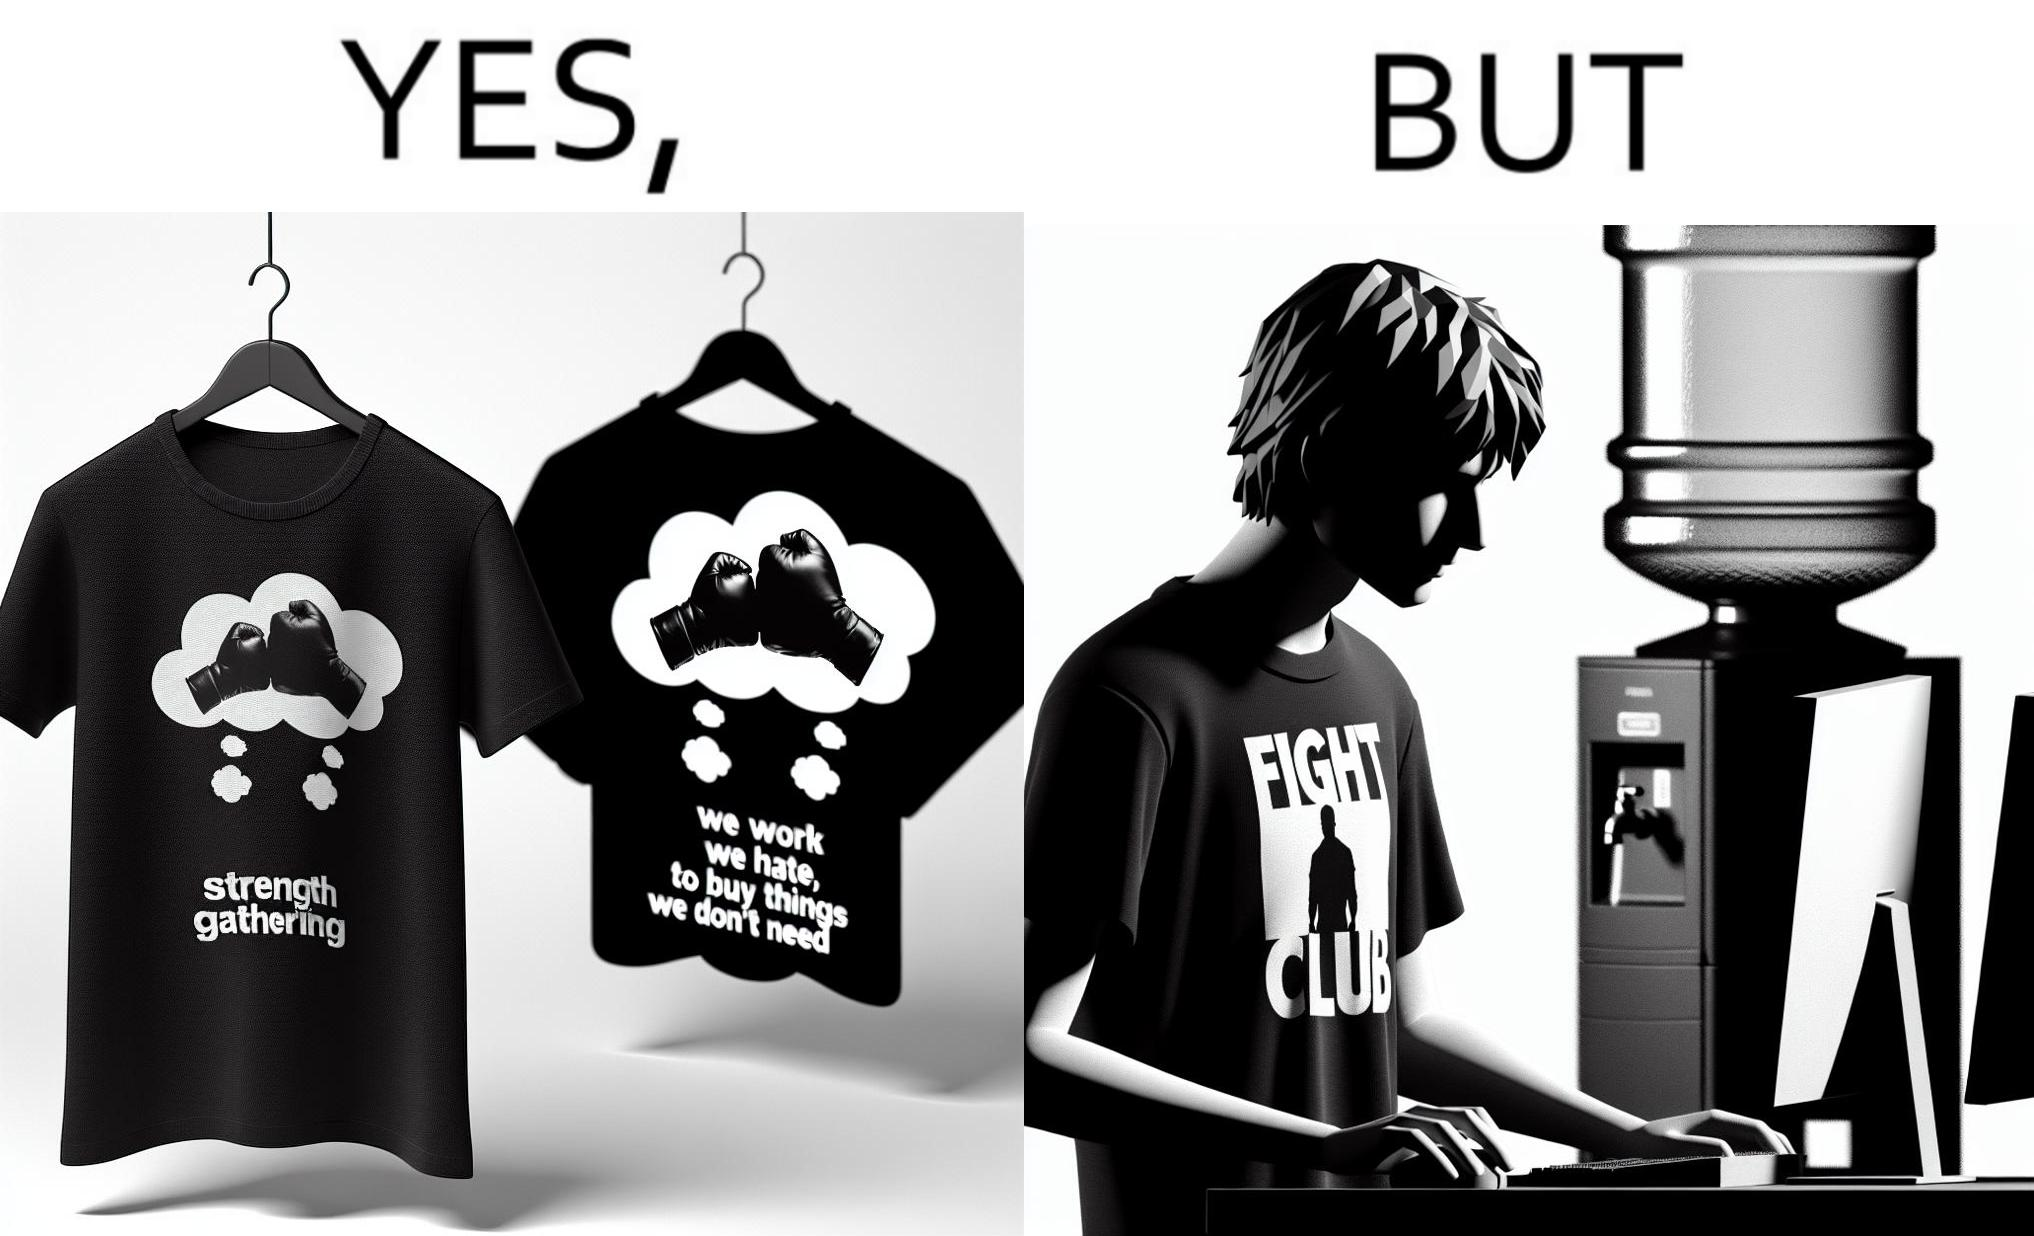Explain the humor or irony in this image. The image is ironical, as the t-shirt says "We work jobs we hate, to buy sh*t we don't need", which is a rebellious message against the construct of office jobs. However, the person wearing the t-shirt seems to be working in an office environment. Also, the t-shirt might have been bought using the money earned via the very same job. 